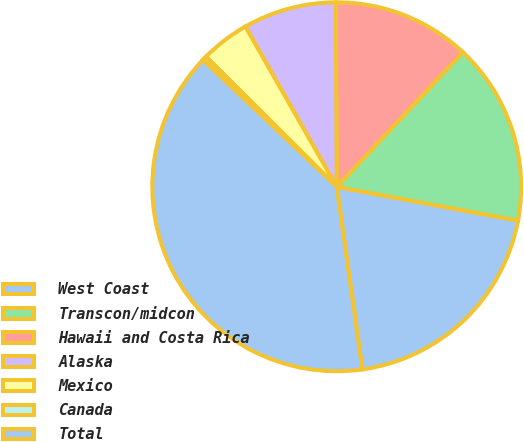Convert chart. <chart><loc_0><loc_0><loc_500><loc_500><pie_chart><fcel>West Coast<fcel>Transcon/midcon<fcel>Hawaii and Costa Rica<fcel>Alaska<fcel>Mexico<fcel>Canada<fcel>Total<nl><fcel>19.84%<fcel>15.95%<fcel>12.06%<fcel>8.17%<fcel>4.28%<fcel>0.39%<fcel>39.29%<nl></chart> 